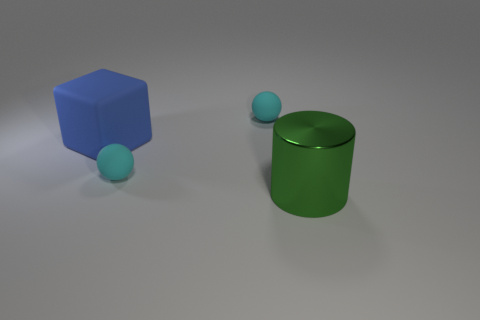Add 2 tiny gray blocks. How many objects exist? 6 Subtract all cylinders. How many objects are left? 3 Add 4 blue matte blocks. How many blue matte blocks are left? 5 Add 4 cylinders. How many cylinders exist? 5 Subtract 0 purple balls. How many objects are left? 4 Subtract all red matte cylinders. Subtract all green things. How many objects are left? 3 